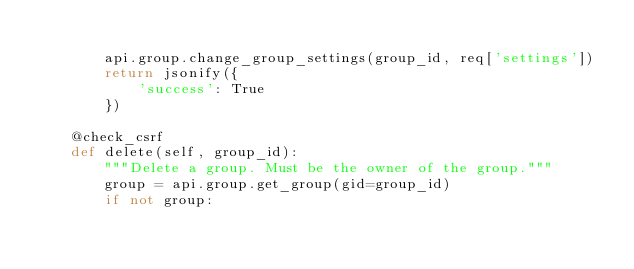Convert code to text. <code><loc_0><loc_0><loc_500><loc_500><_Python_>
        api.group.change_group_settings(group_id, req['settings'])
        return jsonify({
            'success': True
        })

    @check_csrf
    def delete(self, group_id):
        """Delete a group. Must be the owner of the group."""
        group = api.group.get_group(gid=group_id)
        if not group:</code> 